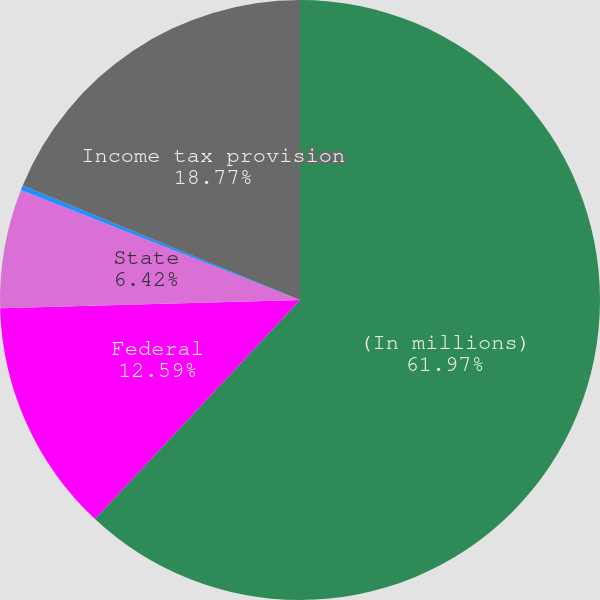Convert chart. <chart><loc_0><loc_0><loc_500><loc_500><pie_chart><fcel>(In millions)<fcel>Federal<fcel>State<fcel>Foreign<fcel>Income tax provision<nl><fcel>61.98%<fcel>12.59%<fcel>6.42%<fcel>0.25%<fcel>18.77%<nl></chart> 